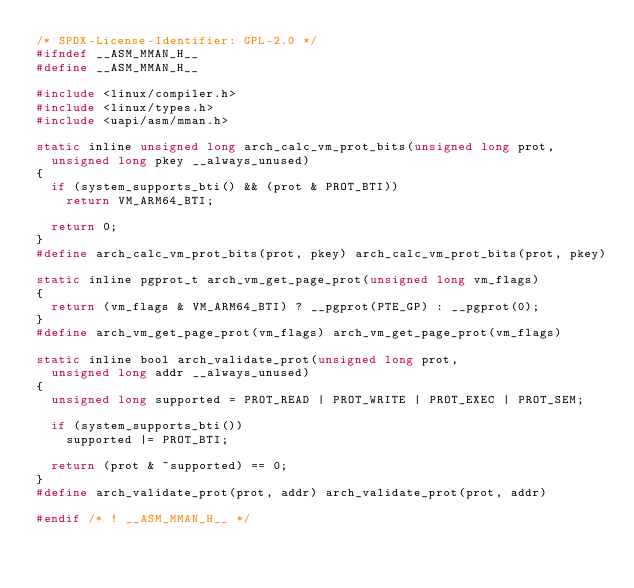<code> <loc_0><loc_0><loc_500><loc_500><_C_>/* SPDX-License-Identifier: GPL-2.0 */
#ifndef __ASM_MMAN_H__
#define __ASM_MMAN_H__

#include <linux/compiler.h>
#include <linux/types.h>
#include <uapi/asm/mman.h>

static inline unsigned long arch_calc_vm_prot_bits(unsigned long prot,
	unsigned long pkey __always_unused)
{
	if (system_supports_bti() && (prot & PROT_BTI))
		return VM_ARM64_BTI;

	return 0;
}
#define arch_calc_vm_prot_bits(prot, pkey) arch_calc_vm_prot_bits(prot, pkey)

static inline pgprot_t arch_vm_get_page_prot(unsigned long vm_flags)
{
	return (vm_flags & VM_ARM64_BTI) ? __pgprot(PTE_GP) : __pgprot(0);
}
#define arch_vm_get_page_prot(vm_flags) arch_vm_get_page_prot(vm_flags)

static inline bool arch_validate_prot(unsigned long prot,
	unsigned long addr __always_unused)
{
	unsigned long supported = PROT_READ | PROT_WRITE | PROT_EXEC | PROT_SEM;

	if (system_supports_bti())
		supported |= PROT_BTI;

	return (prot & ~supported) == 0;
}
#define arch_validate_prot(prot, addr) arch_validate_prot(prot, addr)

#endif /* ! __ASM_MMAN_H__ */
</code> 